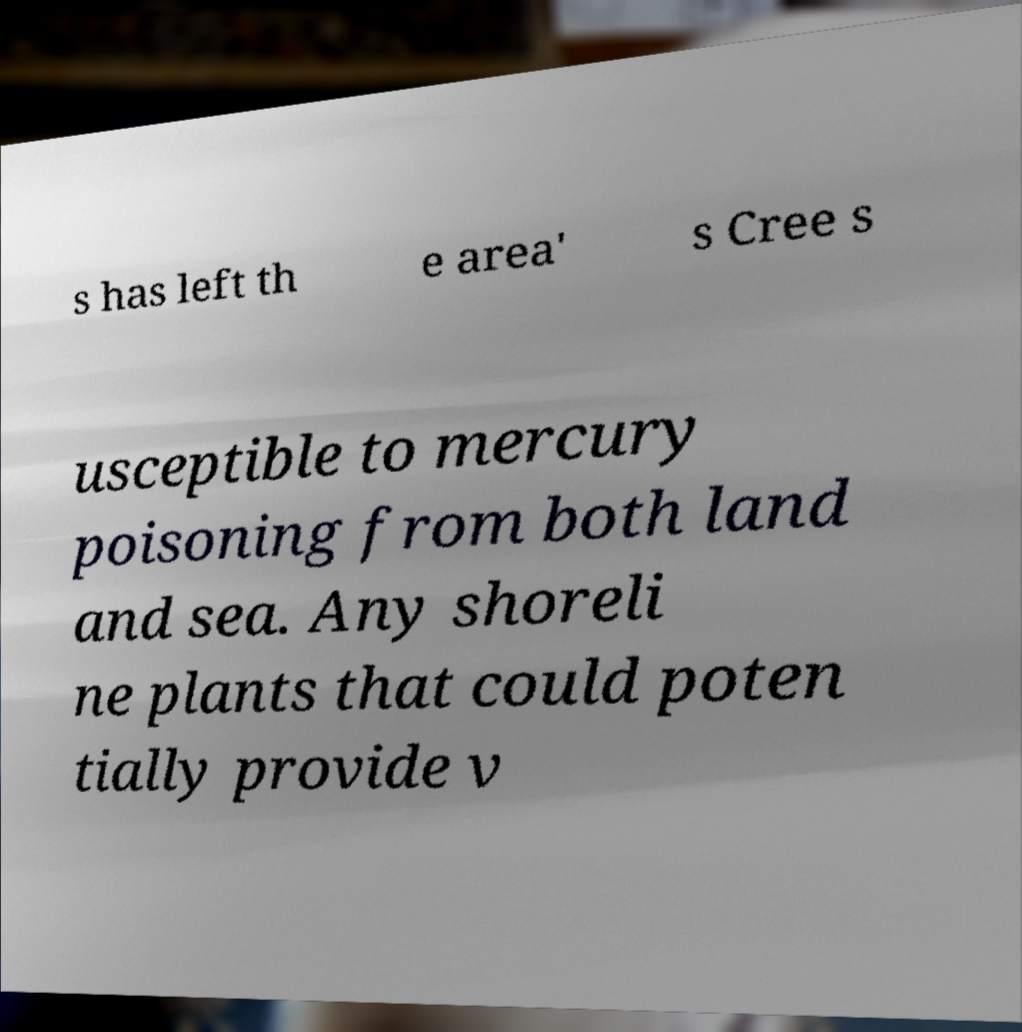I need the written content from this picture converted into text. Can you do that? s has left th e area' s Cree s usceptible to mercury poisoning from both land and sea. Any shoreli ne plants that could poten tially provide v 